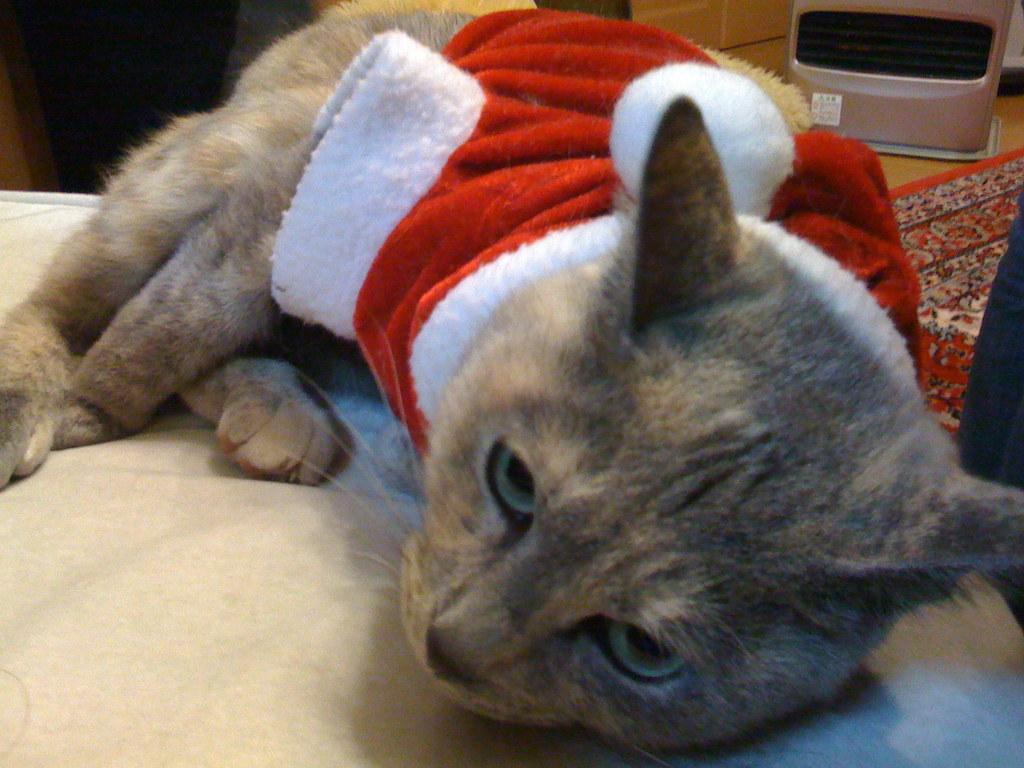What type of animal is on the bed in the image? There is a cat on the bed in the image. Can you describe the object in the background of the image? Unfortunately, the facts provided do not give any details about the object in the background. How many friends are playing with the sponge in the image? There is no sponge or friends present in the image; it only features a cat on the bed. 